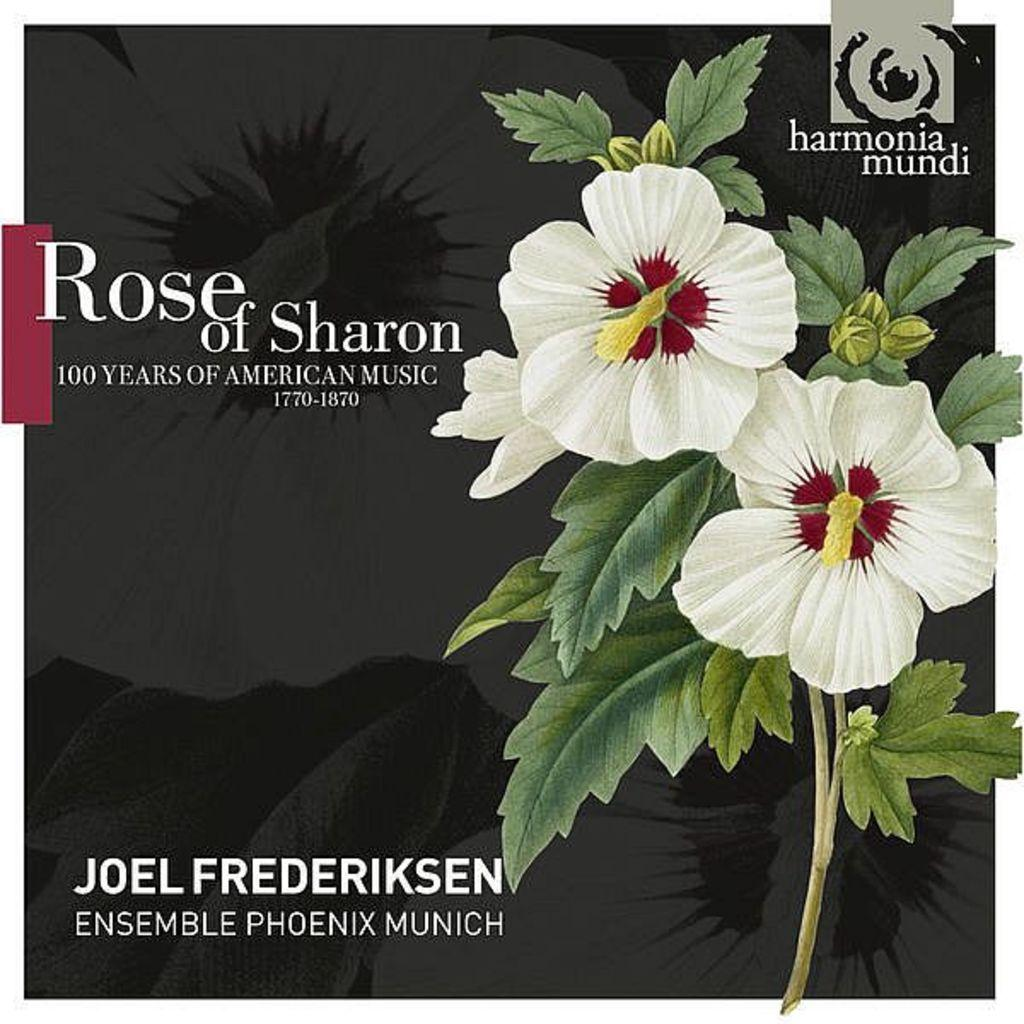What is the main subject of the picture? The main subject of the picture is a cartoon image of flowers. What can be seen on the cartoon image? There is something written on the cartoon image. What type of smoke can be seen coming from the flowers in the image? There is no smoke present in the image; it features a cartoon image of flowers with writing on it. What type of war is depicted in the image? There is no war depicted in the image; it features a cartoon image of flowers with writing on it. 